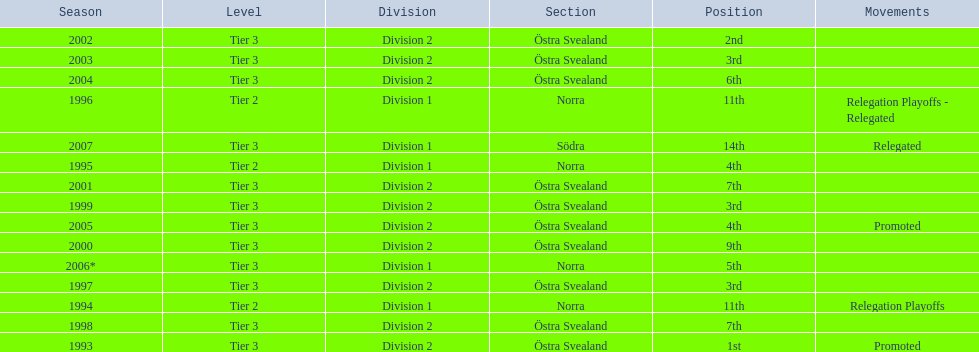How many times did they finish above 5th place in division 2 tier 3? 6. 